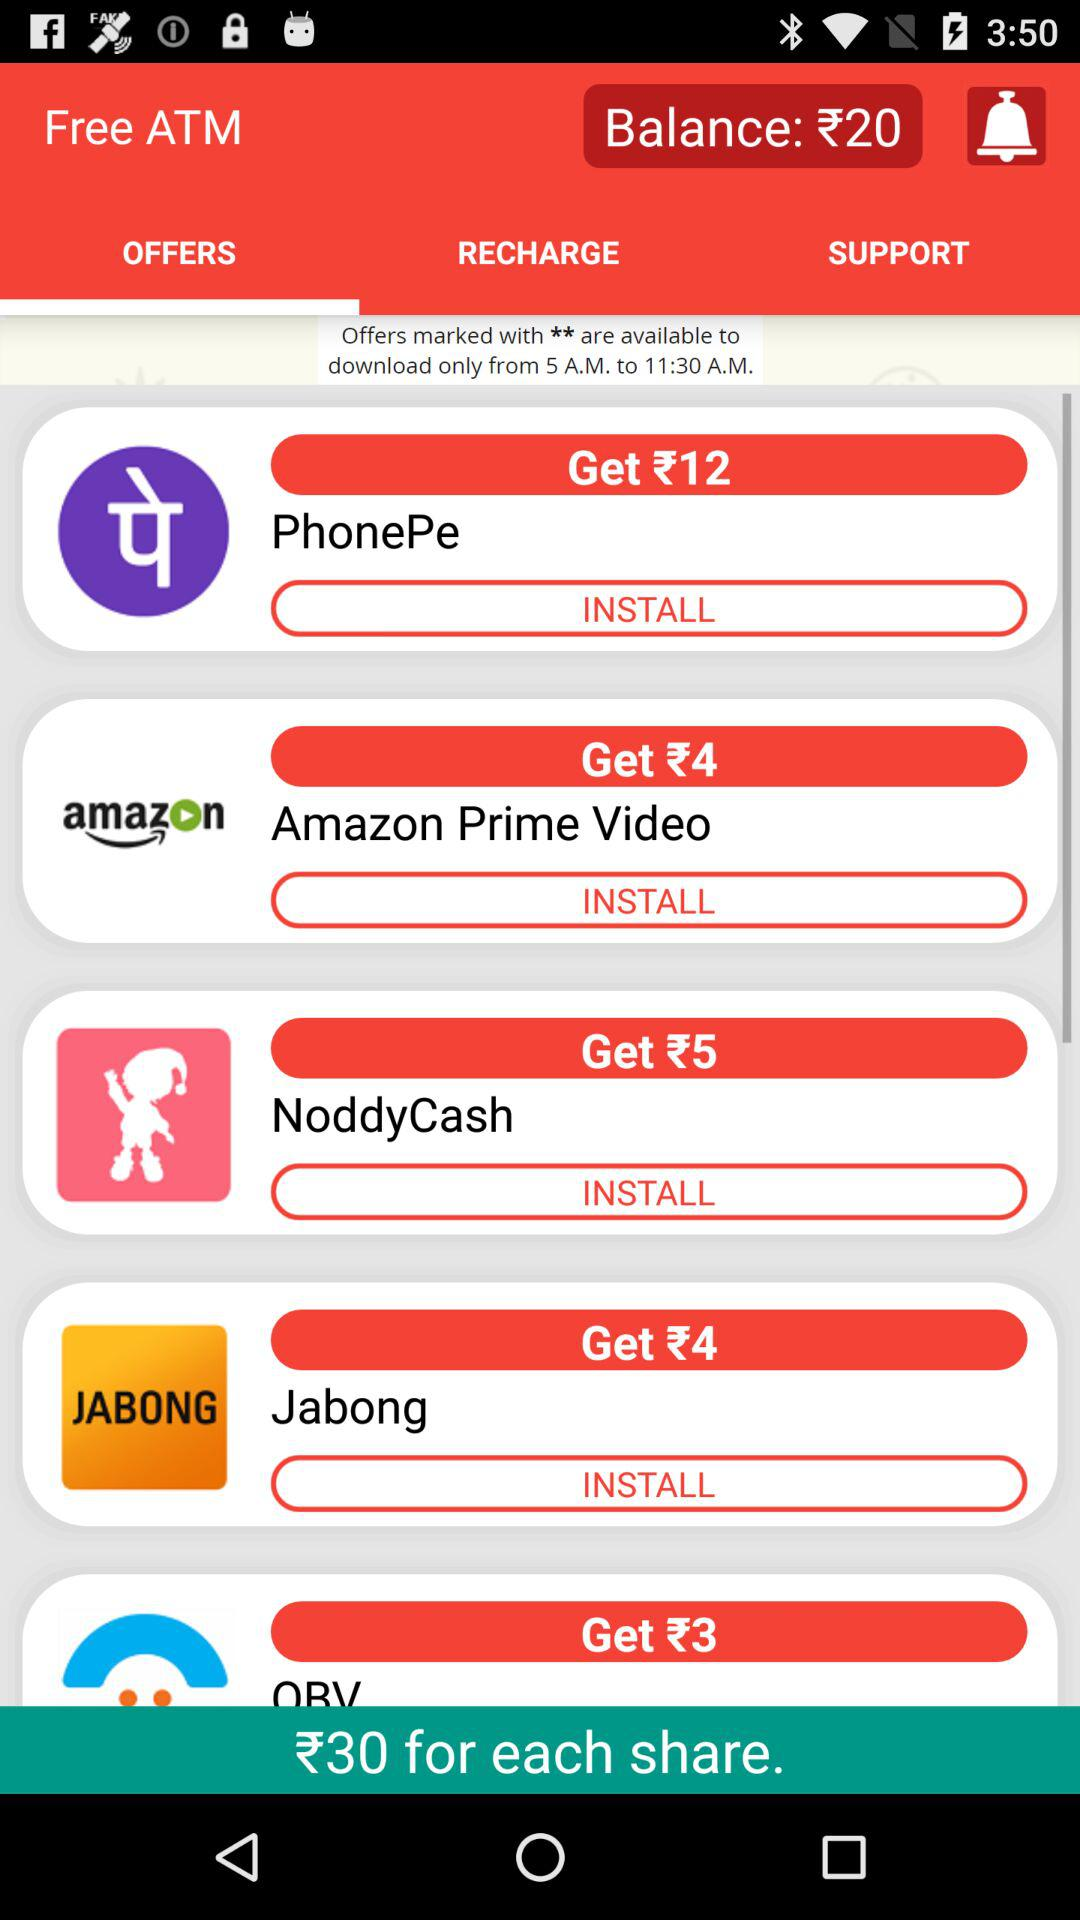How many offers are there in total?
Answer the question using a single word or phrase. 5 